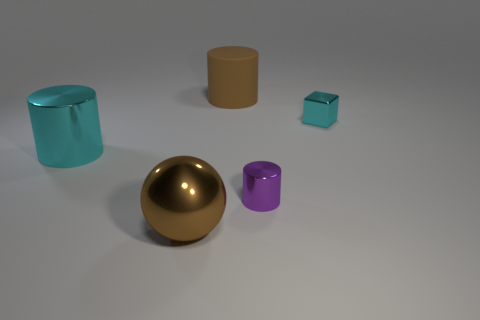Subtract all cyan cylinders. How many cylinders are left? 2 Subtract all shiny cylinders. How many cylinders are left? 1 Add 3 purple cylinders. How many objects exist? 8 Subtract all cylinders. How many objects are left? 2 Subtract 1 cylinders. How many cylinders are left? 2 Subtract all gray cubes. How many purple cylinders are left? 1 Subtract all large cyan cylinders. Subtract all small metal cylinders. How many objects are left? 3 Add 5 tiny cyan objects. How many tiny cyan objects are left? 6 Add 4 cylinders. How many cylinders exist? 7 Subtract 0 brown blocks. How many objects are left? 5 